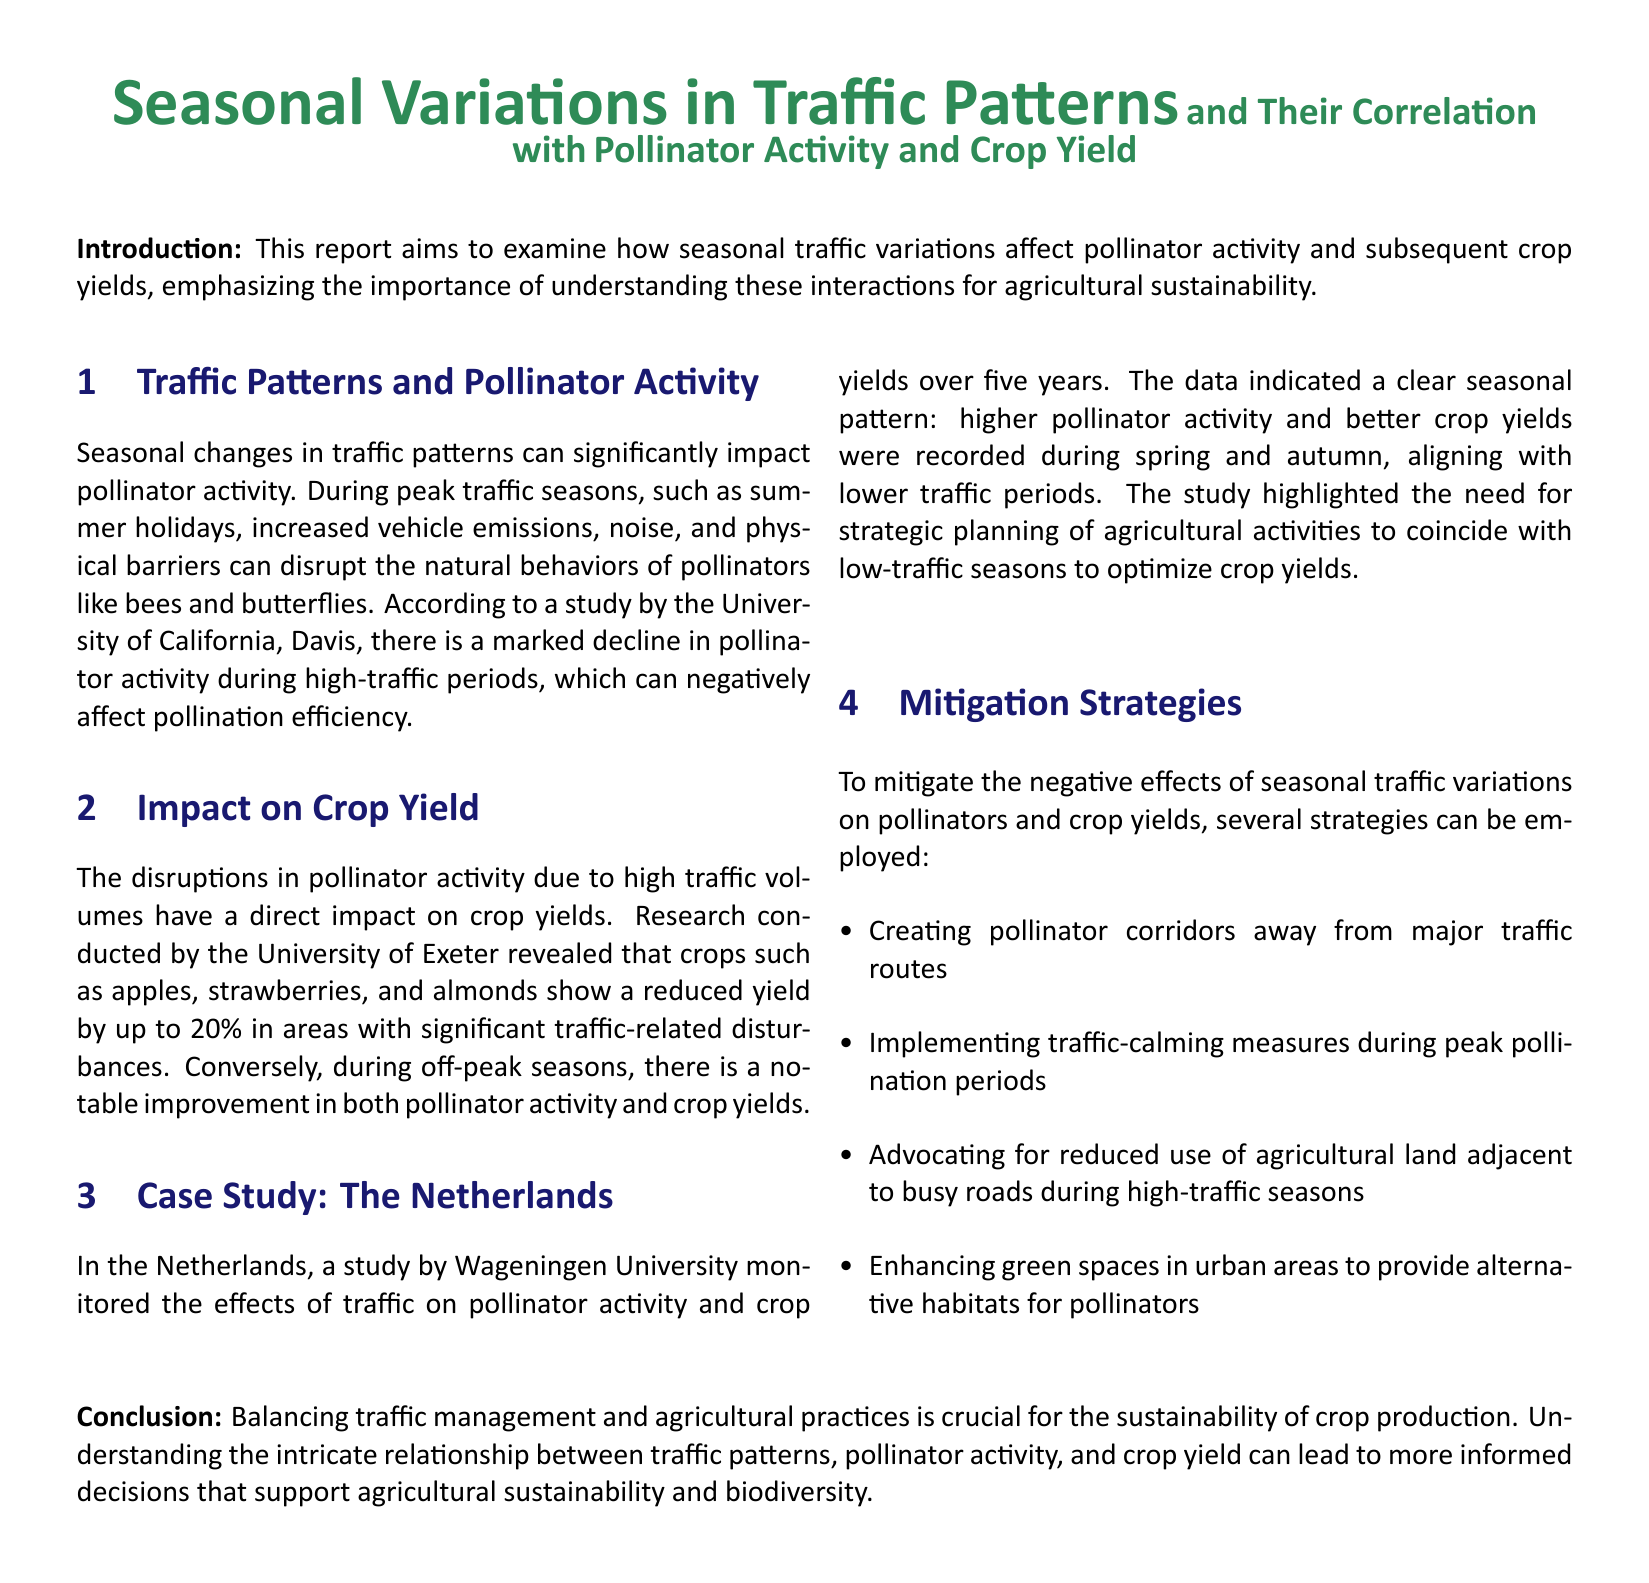What is the main focus of the report? The report aims to examine how seasonal traffic variations affect pollinator activity and subsequent crop yields.
Answer: Traffic variations and their effect on pollinators and crop yields Which university conducted research on crop yield reductions? The report mentions a study by the University of Exeter regarding crop yields affected by traffic-related disturbances.
Answer: University of Exeter What percentage of crop yield reduction is noted in high traffic areas? The document states that crops show a reduced yield by up to 20% in areas with significant traffic-related disturbances.
Answer: 20% During which seasons were higher pollinator activity and better crop yields recorded in the Netherlands study? The case study mentions that higher pollinator activity and better crop yields were recorded during spring and autumn.
Answer: Spring and autumn What mitigation strategy involves creating habitats for pollinators? Enhancing green spaces in urban areas is mentioned as a strategy to provide alternative habitats for pollinators.
Answer: Enhancing green spaces What is the role of traffic calming measures according to the report? The report suggests implementing traffic-calming measures during peak pollination periods to mitigate negative effects.
Answer: Mitigation of negative effects during peak pollination How many years did the Netherlands study monitor traffic and crop yield effects? The study monitored the effects of traffic on pollinator activity and crop yields over five years.
Answer: Five years 